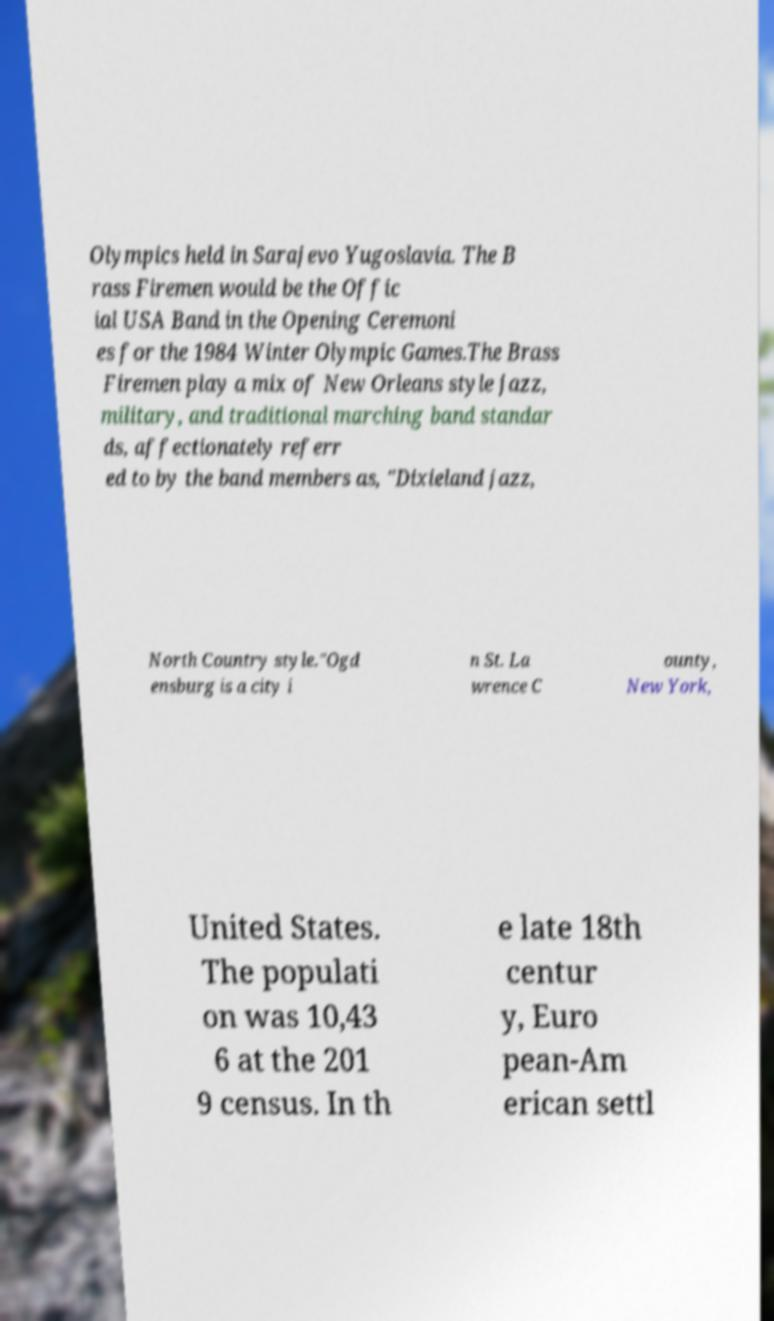Could you assist in decoding the text presented in this image and type it out clearly? Olympics held in Sarajevo Yugoslavia. The B rass Firemen would be the Offic ial USA Band in the Opening Ceremoni es for the 1984 Winter Olympic Games.The Brass Firemen play a mix of New Orleans style jazz, military, and traditional marching band standar ds, affectionately referr ed to by the band members as, "Dixieland jazz, North Country style."Ogd ensburg is a city i n St. La wrence C ounty, New York, United States. The populati on was 10,43 6 at the 201 9 census. In th e late 18th centur y, Euro pean-Am erican settl 